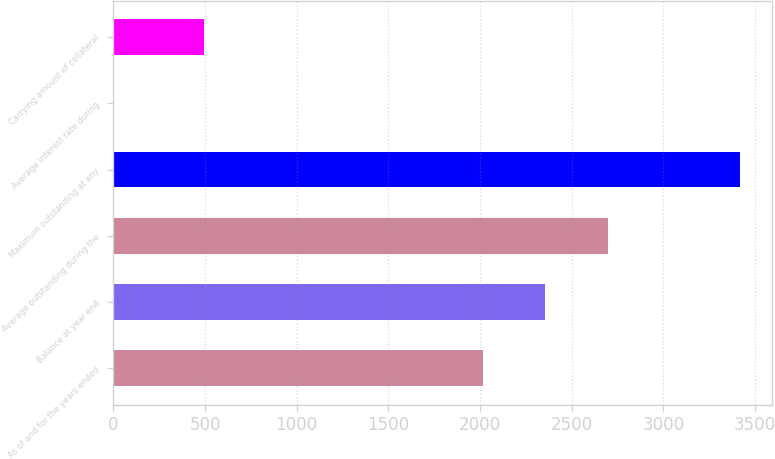Convert chart to OTSL. <chart><loc_0><loc_0><loc_500><loc_500><bar_chart><fcel>As of and for the years ended<fcel>Balance at year end<fcel>Average outstanding during the<fcel>Maximum outstanding at any<fcel>Average interest rate during<fcel>Carrying amount of collateral<nl><fcel>2014<fcel>2355.91<fcel>2697.82<fcel>3419.5<fcel>0.36<fcel>495.7<nl></chart> 